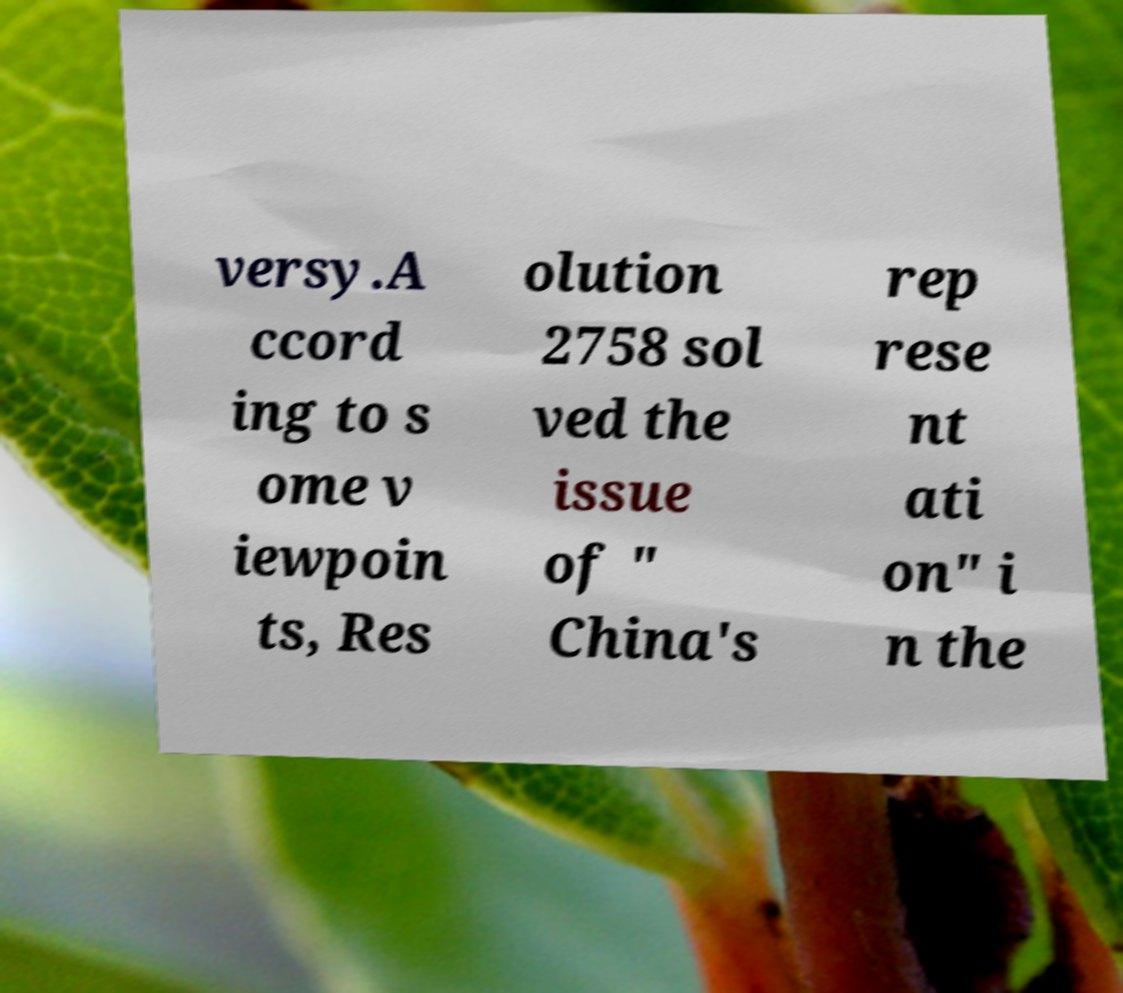For documentation purposes, I need the text within this image transcribed. Could you provide that? versy.A ccord ing to s ome v iewpoin ts, Res olution 2758 sol ved the issue of " China's rep rese nt ati on" i n the 